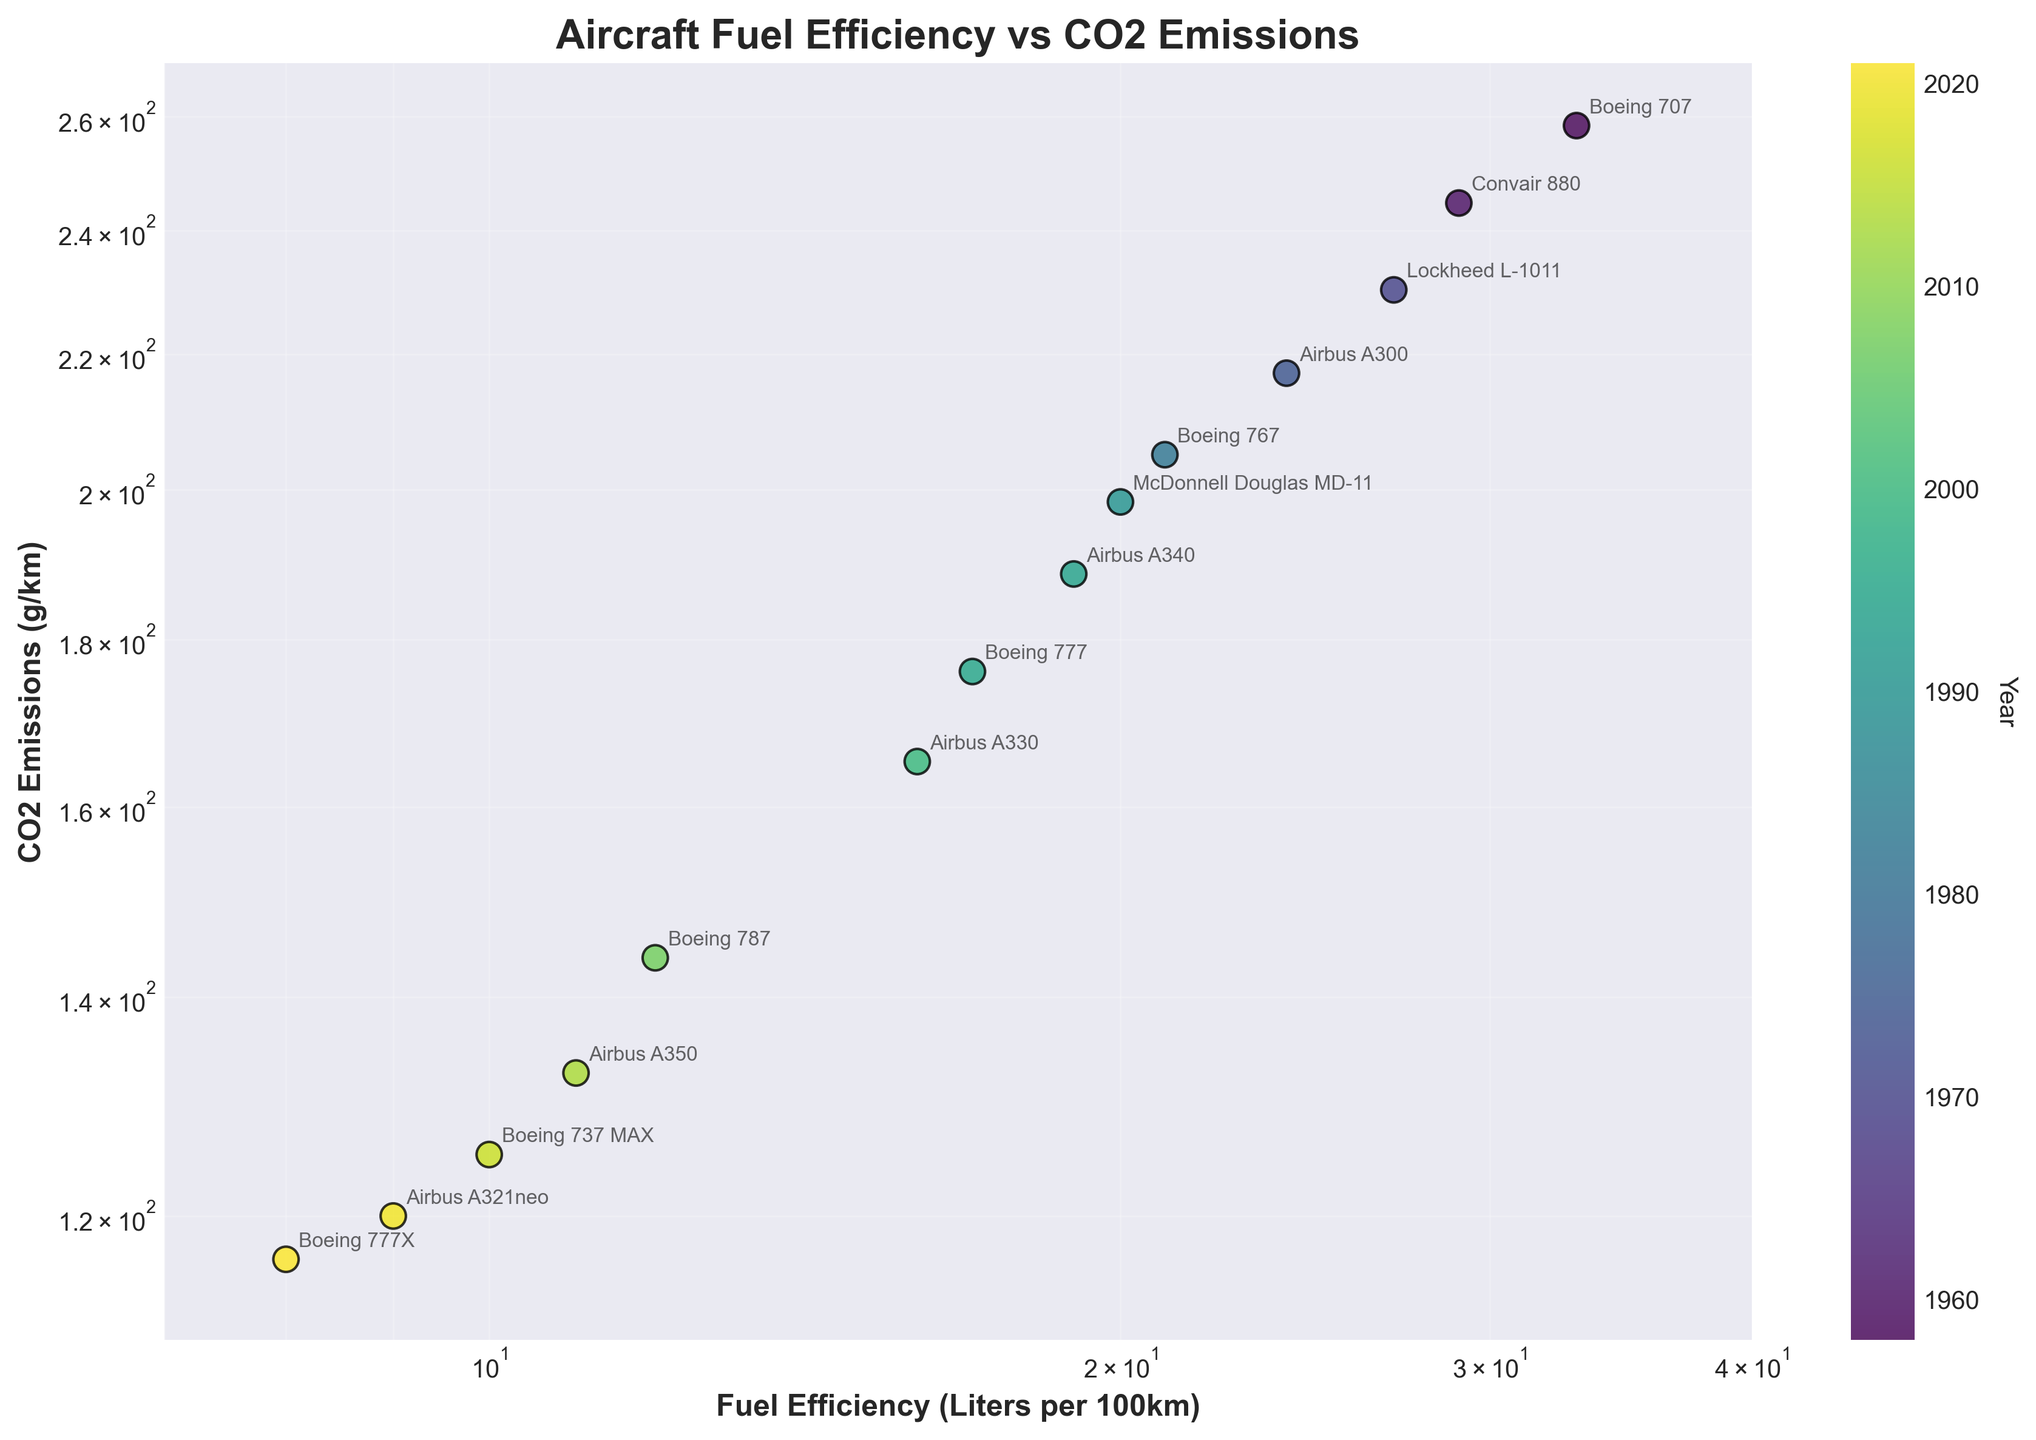What's the title of the figure? The title of the figure is usually placed at the top center and is often in a larger font size. Here, it reads "Aircraft Fuel Efficiency vs CO2 Emissions" in bold letters.
Answer: Aircraft Fuel Efficiency vs CO2 Emissions What do the x and y axes represent? The labels on the x and y axes describe what each axis represents. The x-axis is labeled "Fuel Efficiency (Liters per 100km)" and the y-axis is labeled "CO2 Emissions (g/km)."
Answer: The x-axis represents Fuel Efficiency (Liters per 100km) and the y-axis represents CO2 Emissions (g/km) Which aircraft model has the highest CO2 emissions and what is its fuel efficiency? Look at the data points and check the values on the y-axis to find the highest CO2 emissions, then refer to the annotation for the aircraft model and the value on the x-axis for fuel efficiency.
Answer: Boeing 707, 33 Liters per 100km What is the trend observed between fuel efficiency and CO2 emissions? Observe the overall pattern of data points. As fuel efficiency improves (lower liters per 100km), CO2 emissions also decrease, indicating a negative correlation between the two variables.
Answer: Negative correlation Which aircraft model from the year 2000 or later has the lowest fuel efficiency rate? Focus on the data points for the years 2000 or later (color-coded and indicated in the legend), then identify the point closest to the lowest end of the x-axis.
Answer: Boeing 777X Among the highlighted aircraft, which one has the least improvement in fuel efficiency compared to the Boeing 707? Compare the fuel efficiency of each individual aircraft model presented in year order and identify the one closest in liters per 100km to the Boeing 707.
Answer: Convair 880 How many aircraft models have a fuel efficiency of less than 15 Liters per 100km? Look at the x-axis and count the number of data points that fall below the 15 Liters per 100km mark.
Answer: 8 Which aircraft model introduced after 2010 has the highest CO2 emissions? Focus on aircraft models introduced after 2010 and compare their y-axis positions to identify which has the highest CO2 emissions.
Answer: Airbus A350 Is the relationship between fuel efficiency and CO2 emissions linear or non-linear, and how can you tell? Examine the overall pattern of data points and consider the log-log scale used in the plot. If the points follow a straight line trend on a log-log scale, it would suggest a potential power-law (non-linear) relationship.
Answer: Non-linear Which year is associated with the highest density of data points and what might this indicate? Use the color-coded legend to identify the year with the most clustered or closely placed points, which might indicate multiple aircraft models were introduced close together in terms of technological advancements.
Answer: 2020s 